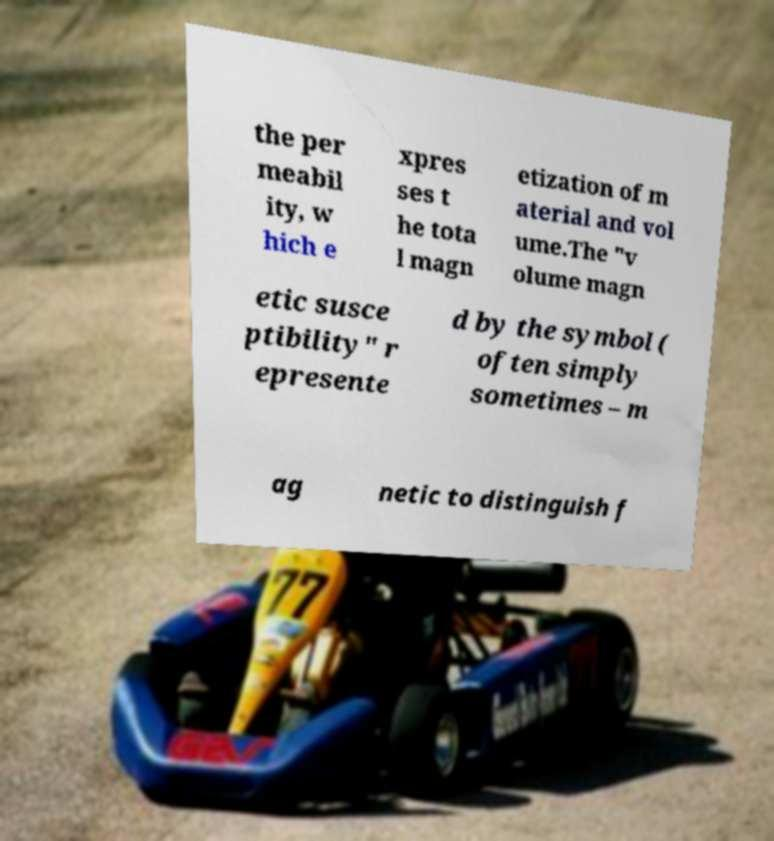What messages or text are displayed in this image? I need them in a readable, typed format. the per meabil ity, w hich e xpres ses t he tota l magn etization of m aterial and vol ume.The "v olume magn etic susce ptibility" r epresente d by the symbol ( often simply sometimes – m ag netic to distinguish f 